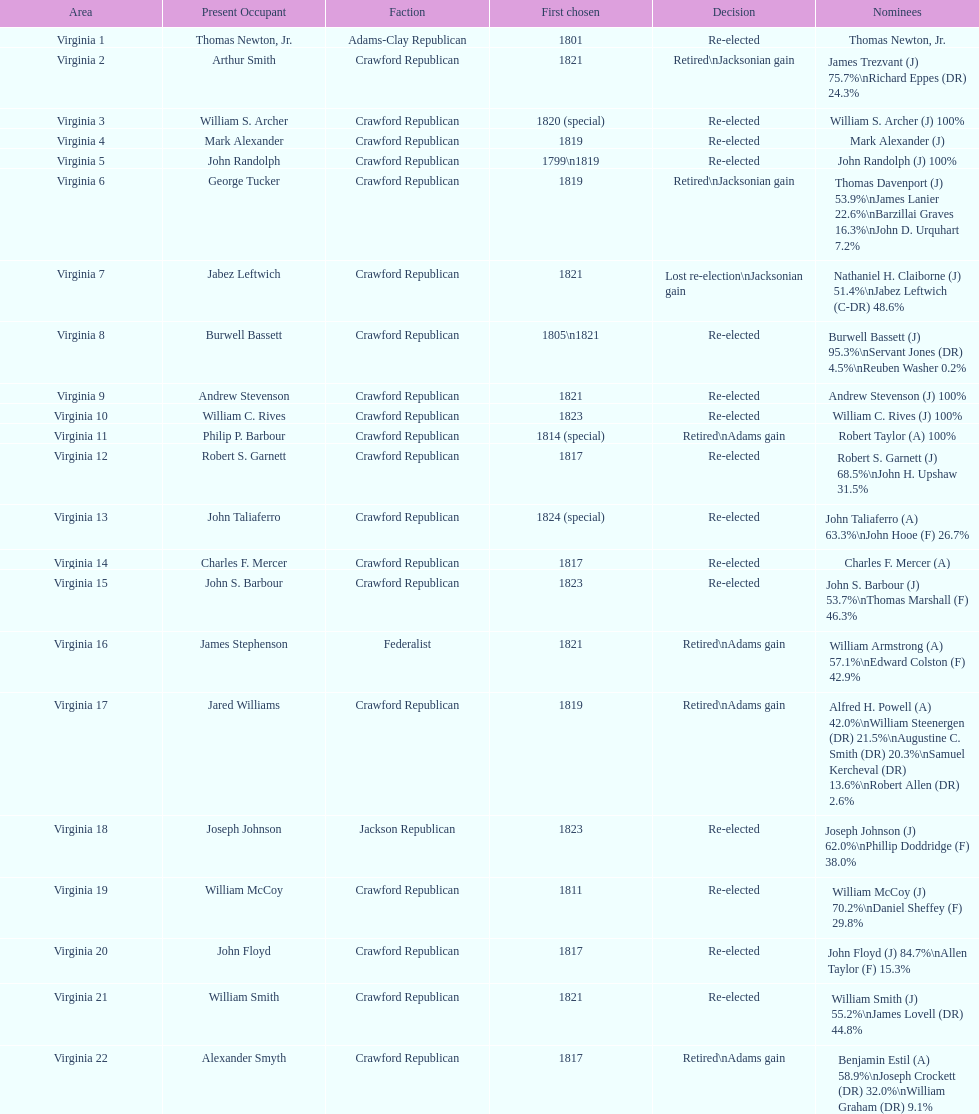Which jacksonian candidates got at least 76% of the vote in their races? Arthur Smith. 